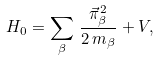Convert formula to latex. <formula><loc_0><loc_0><loc_500><loc_500>H _ { 0 } = \sum _ { \beta } \, \frac { \vec { \pi } _ { \beta } ^ { 2 } } { 2 \, m _ { \beta } } + V ,</formula> 